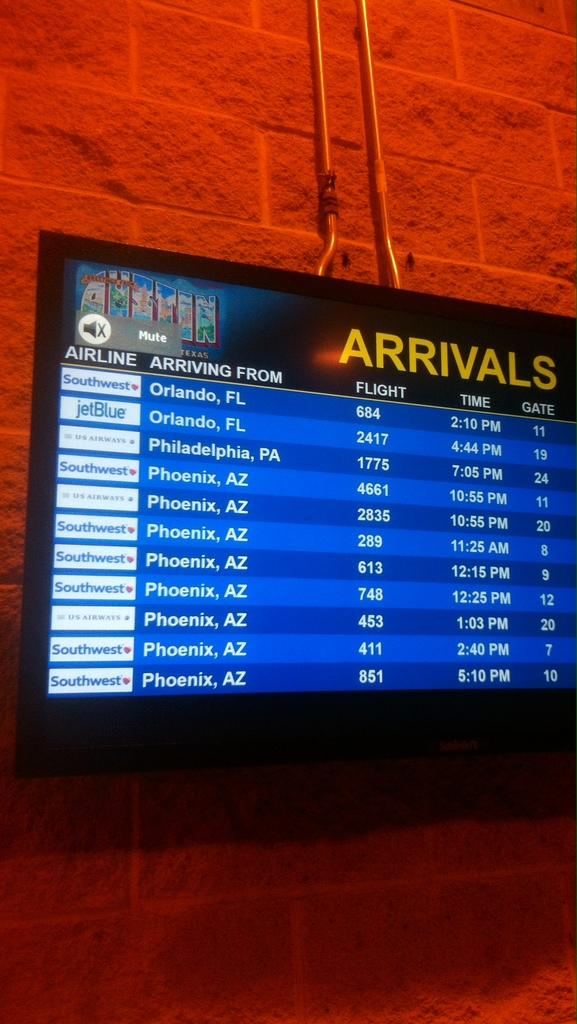<image>
Give a short and clear explanation of the subsequent image. An airport arrivals sign showing Greetings from Austin Texas 